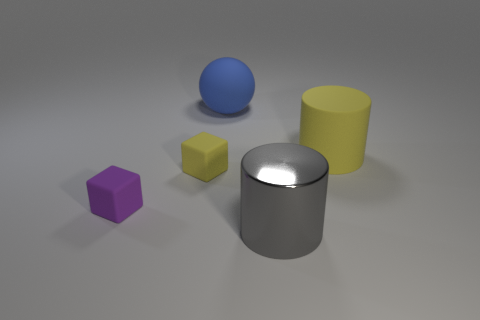Add 4 big blue rubber balls. How many objects exist? 9 Subtract all cubes. How many objects are left? 3 Subtract all tiny gray metallic objects. Subtract all small yellow rubber objects. How many objects are left? 4 Add 4 big things. How many big things are left? 7 Add 2 large yellow things. How many large yellow things exist? 3 Subtract 0 green cubes. How many objects are left? 5 Subtract all red cylinders. Subtract all blue blocks. How many cylinders are left? 2 